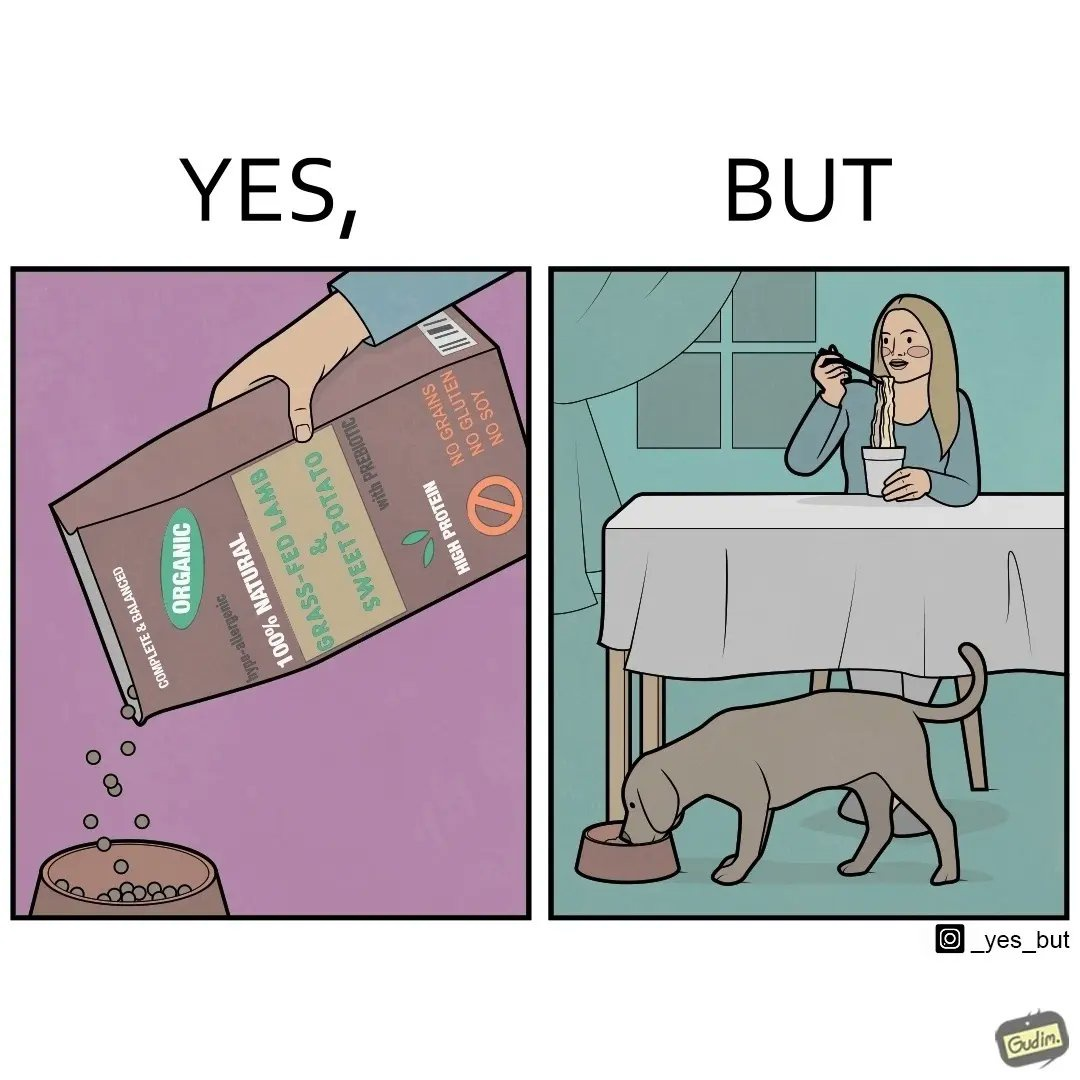Explain the humor or irony in this image. The image is funny because while the food for the dog that the woman pours is well balanced, the food that she herself is eating is bad for her health. 